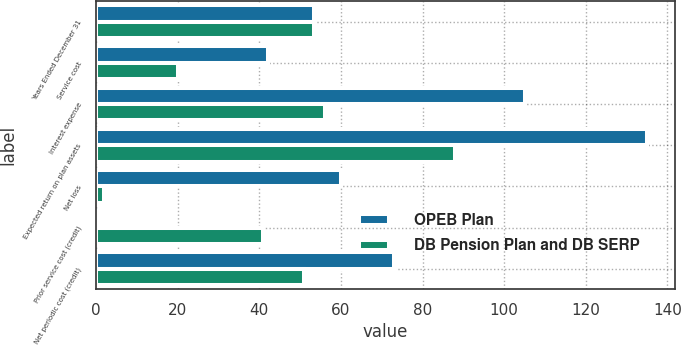Convert chart to OTSL. <chart><loc_0><loc_0><loc_500><loc_500><stacked_bar_chart><ecel><fcel>Years Ended December 31<fcel>Service cost<fcel>Interest expense<fcel>Expected return on plan assets<fcel>Net loss<fcel>Prior service cost (credit)<fcel>Net periodic cost (credit)<nl><fcel>OPEB Plan<fcel>53.5<fcel>42<fcel>105<fcel>135<fcel>60<fcel>1<fcel>73<nl><fcel>DB Pension Plan and DB SERP<fcel>53.5<fcel>20<fcel>56<fcel>88<fcel>2<fcel>41<fcel>51<nl></chart> 